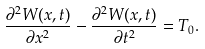Convert formula to latex. <formula><loc_0><loc_0><loc_500><loc_500>\frac { \partial ^ { 2 } W ( x , t ) } { \partial x ^ { 2 } } - \frac { \partial ^ { 2 } W ( x , t ) } { \partial t ^ { 2 } } = T _ { 0 } .</formula> 